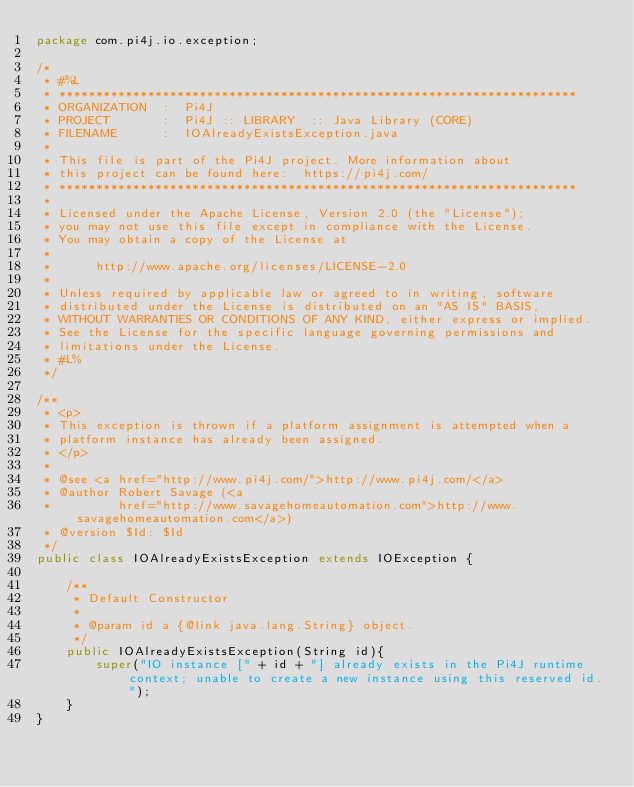Convert code to text. <code><loc_0><loc_0><loc_500><loc_500><_Java_>package com.pi4j.io.exception;

/*
 * #%L
 * **********************************************************************
 * ORGANIZATION  :  Pi4J
 * PROJECT       :  Pi4J :: LIBRARY  :: Java Library (CORE)
 * FILENAME      :  IOAlreadyExistsException.java
 *
 * This file is part of the Pi4J project. More information about
 * this project can be found here:  https://pi4j.com/
 * **********************************************************************
 *
 * Licensed under the Apache License, Version 2.0 (the "License");
 * you may not use this file except in compliance with the License.
 * You may obtain a copy of the License at
 *
 *      http://www.apache.org/licenses/LICENSE-2.0
 *
 * Unless required by applicable law or agreed to in writing, software
 * distributed under the License is distributed on an "AS IS" BASIS,
 * WITHOUT WARRANTIES OR CONDITIONS OF ANY KIND, either express or implied.
 * See the License for the specific language governing permissions and
 * limitations under the License.
 * #L%
 */

/**
 * <p>
 * This exception is thrown if a platform assignment is attempted when a
 * platform instance has already been assigned.
 * </p>
 *
 * @see <a href="http://www.pi4j.com/">http://www.pi4j.com/</a>
 * @author Robert Savage (<a
 *         href="http://www.savagehomeautomation.com">http://www.savagehomeautomation.com</a>)
 * @version $Id: $Id
 */
public class IOAlreadyExistsException extends IOException {

    /**
     * Default Constructor
     *
     * @param id a {@link java.lang.String} object.
     */
    public IOAlreadyExistsException(String id){
        super("IO instance [" + id + "] already exists in the Pi4J runtime context; unable to create a new instance using this reserved id.");
    }
}
</code> 